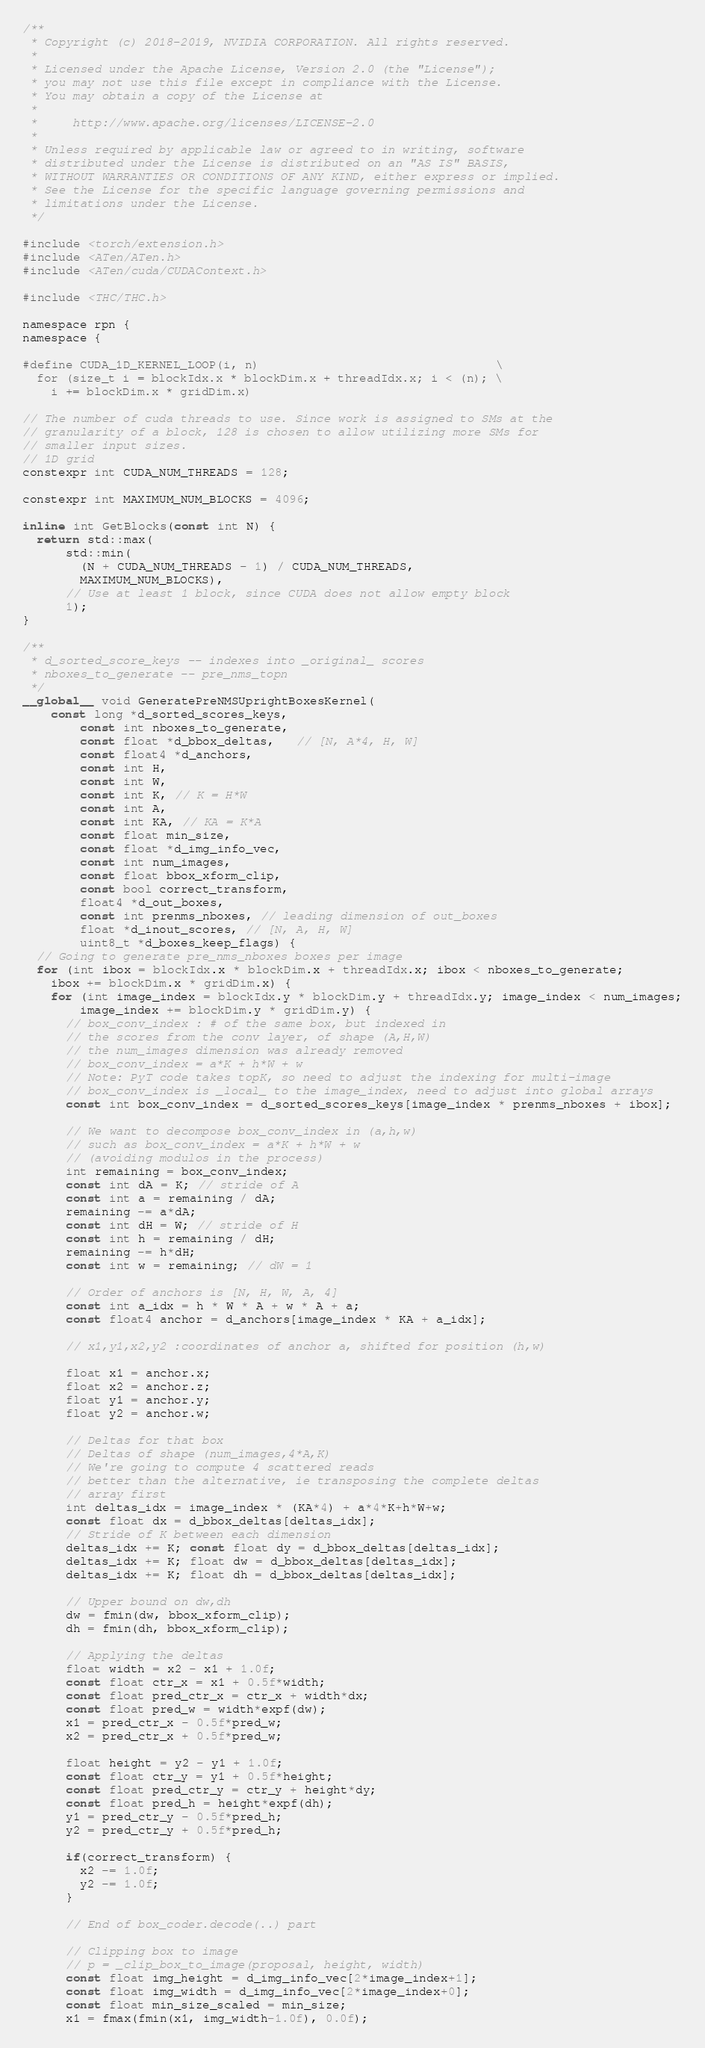Convert code to text. <code><loc_0><loc_0><loc_500><loc_500><_Cuda_>/**
 * Copyright (c) 2018-2019, NVIDIA CORPORATION. All rights reserved.
 *
 * Licensed under the Apache License, Version 2.0 (the "License");
 * you may not use this file except in compliance with the License.
 * You may obtain a copy of the License at
 *
 *     http://www.apache.org/licenses/LICENSE-2.0
 *
 * Unless required by applicable law or agreed to in writing, software
 * distributed under the License is distributed on an "AS IS" BASIS,
 * WITHOUT WARRANTIES OR CONDITIONS OF ANY KIND, either express or implied.
 * See the License for the specific language governing permissions and
 * limitations under the License.
 */

#include <torch/extension.h>
#include <ATen/ATen.h>
#include <ATen/cuda/CUDAContext.h>

#include <THC/THC.h>

namespace rpn {
namespace {

#define CUDA_1D_KERNEL_LOOP(i, n)                                 \
  for (size_t i = blockIdx.x * blockDim.x + threadIdx.x; i < (n); \
    i += blockDim.x * gridDim.x)

// The number of cuda threads to use. Since work is assigned to SMs at the
// granularity of a block, 128 is chosen to allow utilizing more SMs for
// smaller input sizes.
// 1D grid
constexpr int CUDA_NUM_THREADS = 128;

constexpr int MAXIMUM_NUM_BLOCKS = 4096;

inline int GetBlocks(const int N) {
  return std::max(
      std::min(
        (N + CUDA_NUM_THREADS - 1) / CUDA_NUM_THREADS,
        MAXIMUM_NUM_BLOCKS),
      // Use at least 1 block, since CUDA does not allow empty block
      1);
}

/**
 * d_sorted_score_keys -- indexes into _original_ scores
 * nboxes_to_generate -- pre_nms_topn
 */
__global__ void GeneratePreNMSUprightBoxesKernel(
    const long *d_sorted_scores_keys,
		const int nboxes_to_generate,
		const float *d_bbox_deltas,   // [N, A*4, H, W]
		const float4 *d_anchors,
		const int H,
		const int W,
		const int K, // K = H*W
		const int A,
		const int KA, // KA = K*A
		const float min_size,
		const float *d_img_info_vec,
		const int num_images,
		const float bbox_xform_clip,
		const bool correct_transform,
		float4 *d_out_boxes,
		const int prenms_nboxes, // leading dimension of out_boxes
		float *d_inout_scores, // [N, A, H, W]
		uint8_t *d_boxes_keep_flags) {
  // Going to generate pre_nms_nboxes boxes per image
  for (int ibox = blockIdx.x * blockDim.x + threadIdx.x; ibox < nboxes_to_generate;
    ibox += blockDim.x * gridDim.x) {
    for (int image_index = blockIdx.y * blockDim.y + threadIdx.y; image_index < num_images;
        image_index += blockDim.y * gridDim.y) {
      // box_conv_index : # of the same box, but indexed in
      // the scores from the conv layer, of shape (A,H,W)
      // the num_images dimension was already removed
      // box_conv_index = a*K + h*W + w
      // Note: PyT code takes topK, so need to adjust the indexing for multi-image
      // box_conv_index is _local_ to the image_index, need to adjust into global arrays
      const int box_conv_index = d_sorted_scores_keys[image_index * prenms_nboxes + ibox];

      // We want to decompose box_conv_index in (a,h,w)
      // such as box_conv_index = a*K + h*W + w
      // (avoiding modulos in the process)
      int remaining = box_conv_index;
      const int dA = K; // stride of A
      const int a = remaining / dA;
      remaining -= a*dA;
      const int dH = W; // stride of H
      const int h = remaining / dH;
      remaining -= h*dH;
      const int w = remaining; // dW = 1

      // Order of anchors is [N, H, W, A, 4]
      const int a_idx = h * W * A + w * A + a;
      const float4 anchor = d_anchors[image_index * KA + a_idx];

      // x1,y1,x2,y2 :coordinates of anchor a, shifted for position (h,w)

      float x1 = anchor.x;
      float x2 = anchor.z;
      float y1 = anchor.y;
      float y2 = anchor.w;

      // Deltas for that box
      // Deltas of shape (num_images,4*A,K)
      // We're going to compute 4 scattered reads
      // better than the alternative, ie transposing the complete deltas
      // array first
      int deltas_idx = image_index * (KA*4) + a*4*K+h*W+w;
      const float dx = d_bbox_deltas[deltas_idx];
      // Stride of K between each dimension
      deltas_idx += K; const float dy = d_bbox_deltas[deltas_idx];
      deltas_idx += K; float dw = d_bbox_deltas[deltas_idx];
      deltas_idx += K; float dh = d_bbox_deltas[deltas_idx];

      // Upper bound on dw,dh
      dw = fmin(dw, bbox_xform_clip);
      dh = fmin(dh, bbox_xform_clip);

      // Applying the deltas
      float width = x2 - x1 + 1.0f;
      const float ctr_x = x1 + 0.5f*width;
      const float pred_ctr_x = ctr_x + width*dx;
      const float pred_w = width*expf(dw);
      x1 = pred_ctr_x - 0.5f*pred_w;
      x2 = pred_ctr_x + 0.5f*pred_w;

      float height = y2 - y1 + 1.0f;
      const float ctr_y = y1 + 0.5f*height;
      const float pred_ctr_y = ctr_y + height*dy;
      const float pred_h = height*expf(dh);
      y1 = pred_ctr_y - 0.5f*pred_h;
      y2 = pred_ctr_y + 0.5f*pred_h;

      if(correct_transform) {
        x2 -= 1.0f;
        y2 -= 1.0f;
      }

      // End of box_coder.decode(..) part

      // Clipping box to image
      // p = _clip_box_to_image(proposal, height, width)
      const float img_height = d_img_info_vec[2*image_index+1];
      const float img_width = d_img_info_vec[2*image_index+0];
      const float min_size_scaled = min_size;
      x1 = fmax(fmin(x1, img_width-1.0f), 0.0f);</code> 